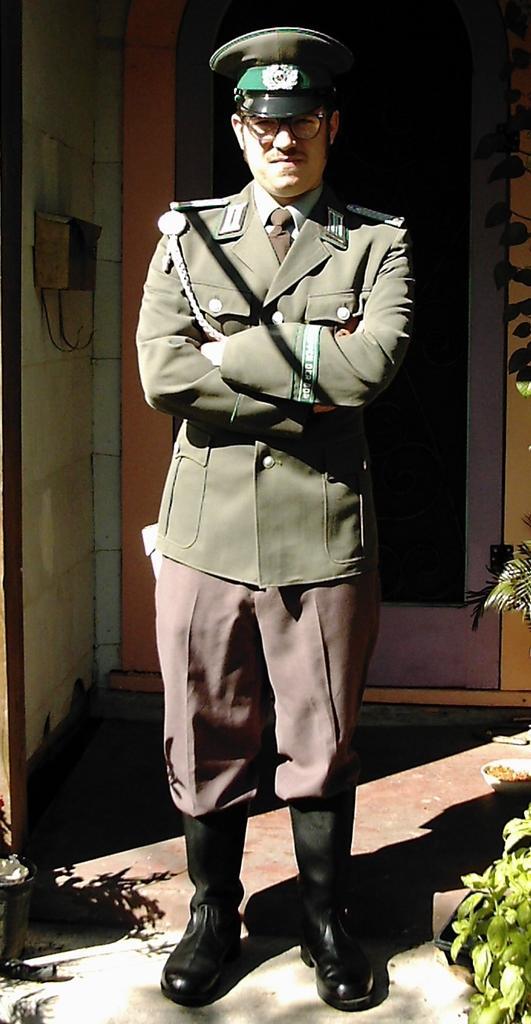Could you give a brief overview of what you see in this image? In this picture there is a person wearing green coat is standing and there are few plants in the right corner and there is a plant pot in the left corner and there is a door and an object behind him. 